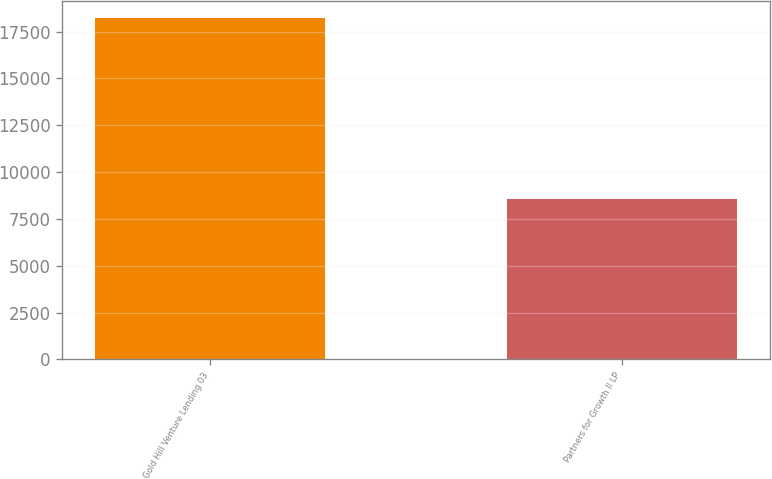<chart> <loc_0><loc_0><loc_500><loc_500><bar_chart><fcel>Gold Hill Venture Lending 03<fcel>Partners for Growth II LP<nl><fcel>18234<fcel>8559<nl></chart> 